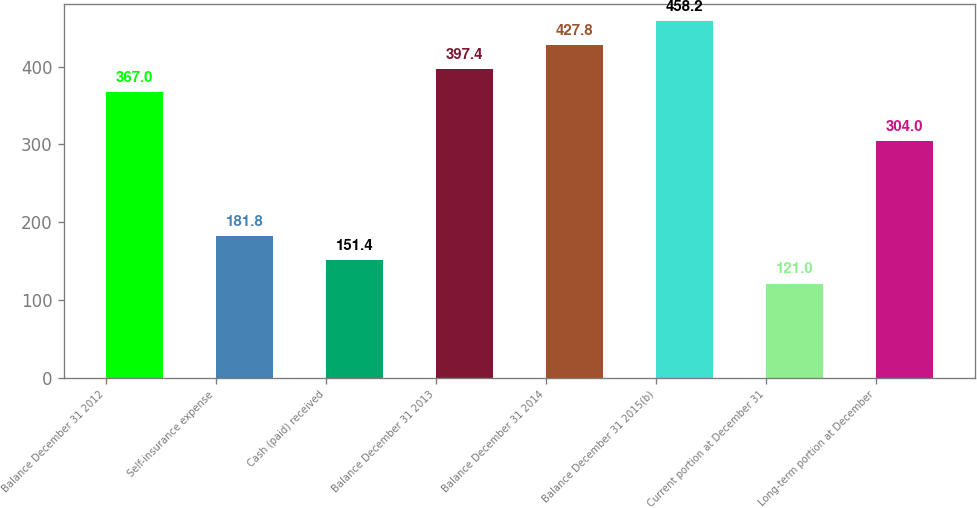<chart> <loc_0><loc_0><loc_500><loc_500><bar_chart><fcel>Balance December 31 2012<fcel>Self-insurance expense<fcel>Cash (paid) received<fcel>Balance December 31 2013<fcel>Balance December 31 2014<fcel>Balance December 31 2015(b)<fcel>Current portion at December 31<fcel>Long-term portion at December<nl><fcel>367<fcel>181.8<fcel>151.4<fcel>397.4<fcel>427.8<fcel>458.2<fcel>121<fcel>304<nl></chart> 